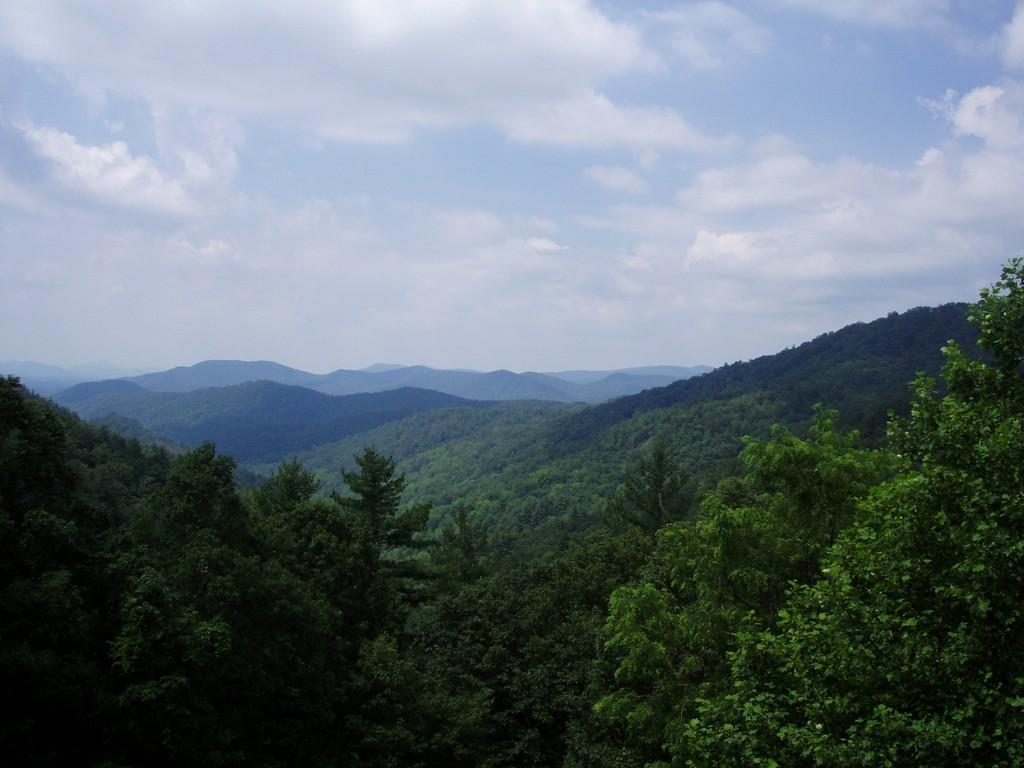What type of natural formation can be seen in the image? There are mountains in the image. What vegetation can be found on the mountains? There are plants and trees on the mountains. What part of the sky is visible in the image? The sky is visible at the top of the mountains in the image. Can you see any feet walking on the mountains in the image? There are no feet or people visible in the image; it only shows mountains, plants, trees, and the sky. 